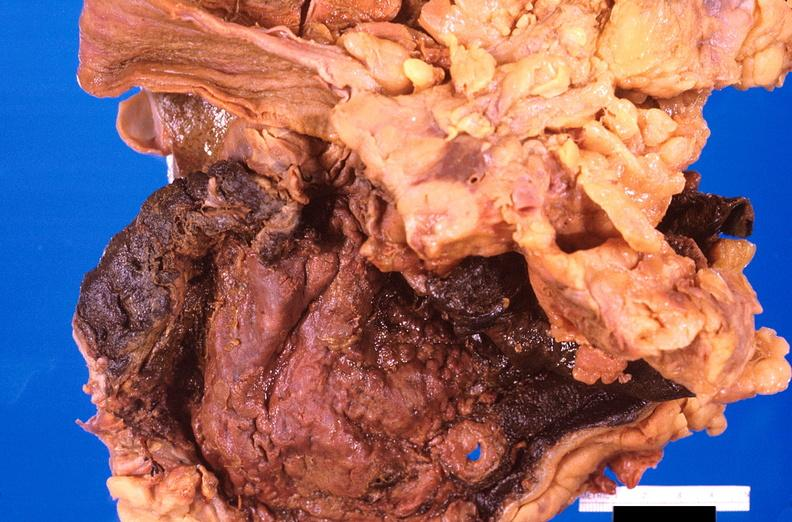s mesentery present?
Answer the question using a single word or phrase. No 